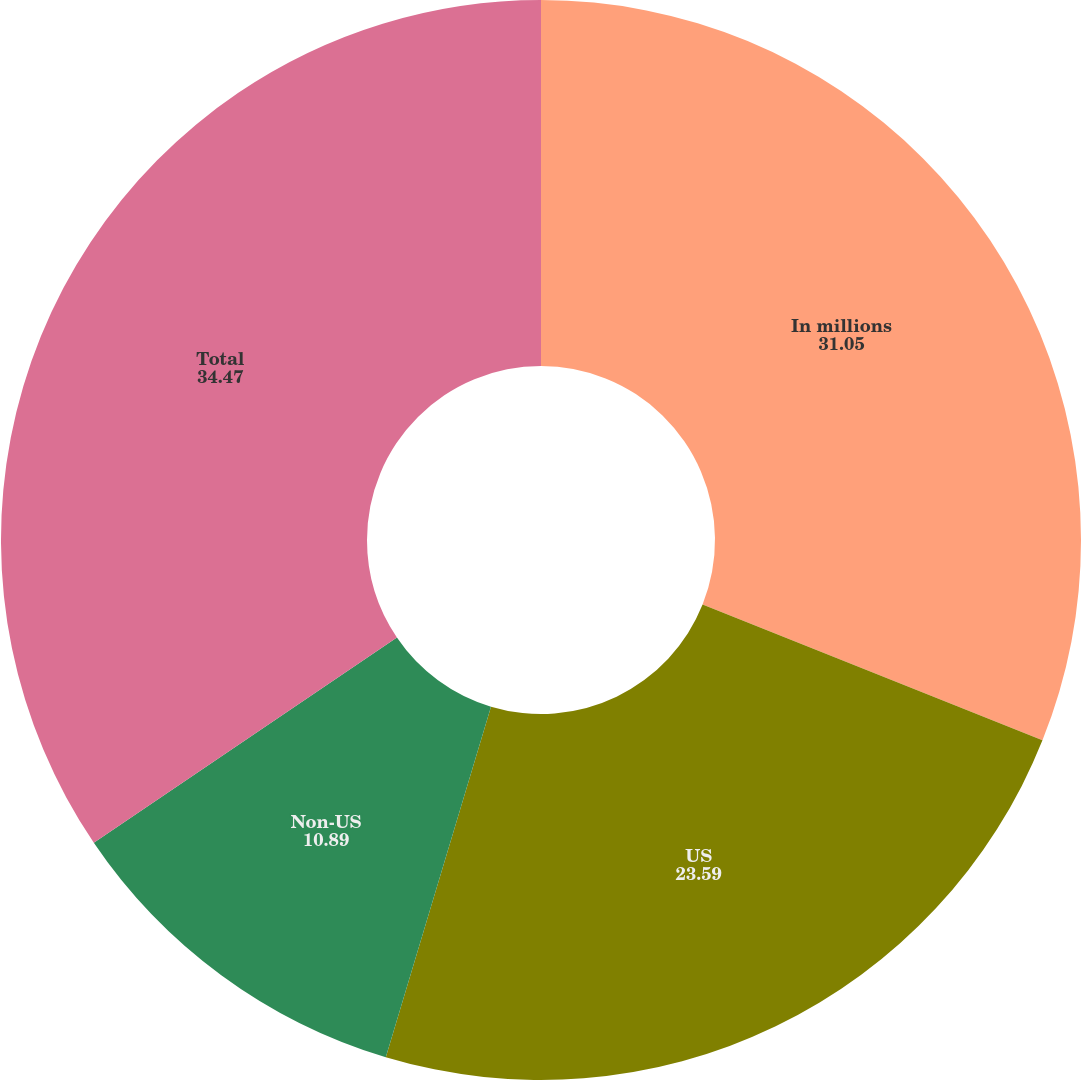Convert chart to OTSL. <chart><loc_0><loc_0><loc_500><loc_500><pie_chart><fcel>In millions<fcel>US<fcel>Non-US<fcel>Total<nl><fcel>31.05%<fcel>23.59%<fcel>10.89%<fcel>34.47%<nl></chart> 